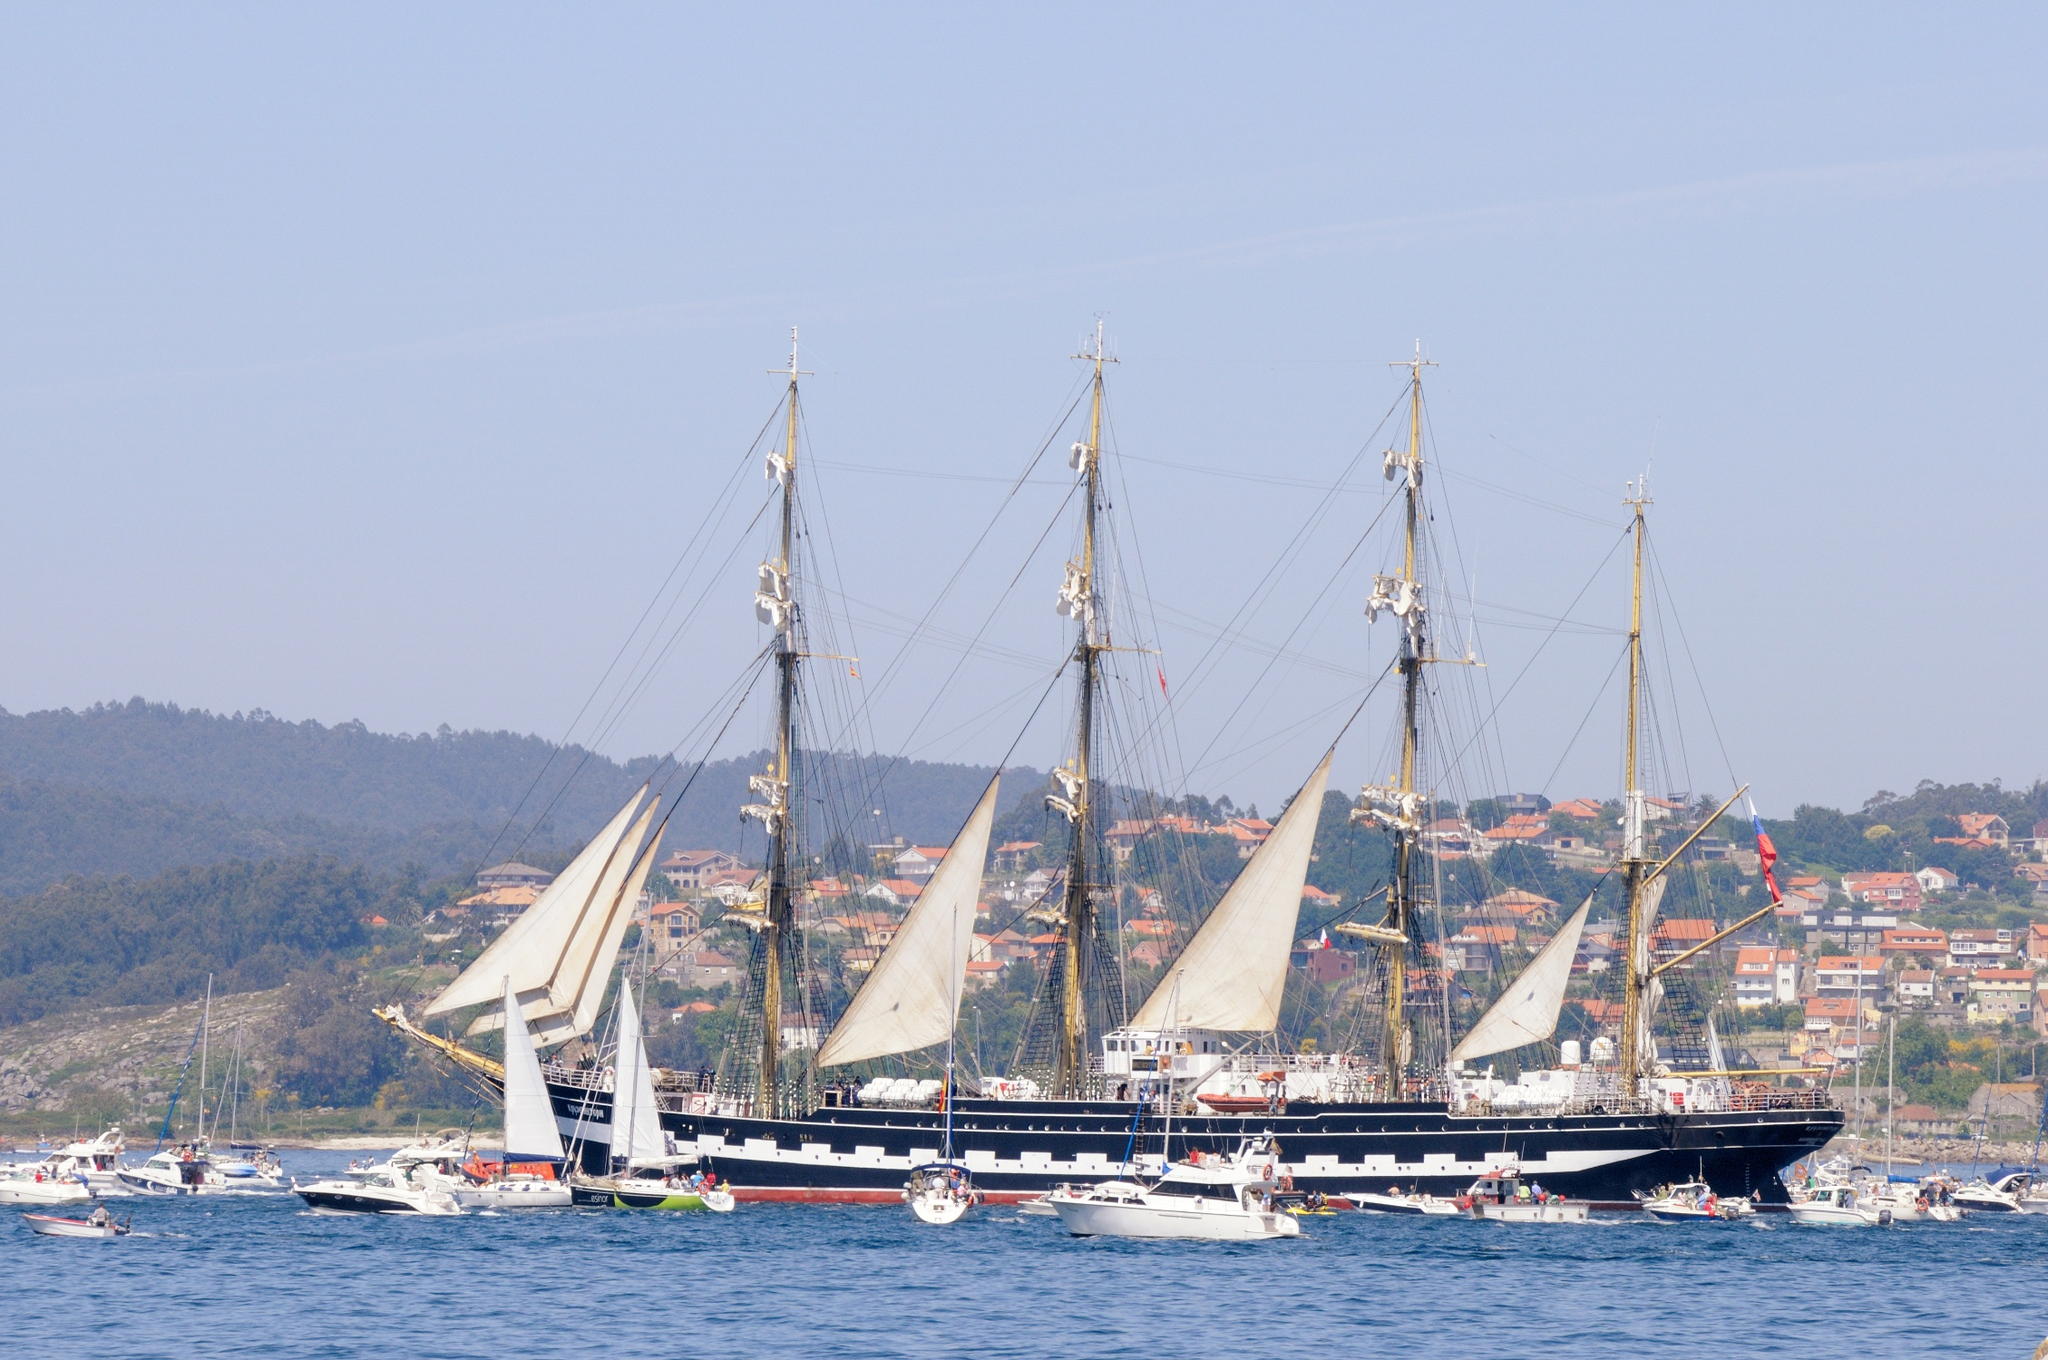What kind of event could this large ship be participating in? This ship, with its classic design and multiple masts, could likely be participating in a maritime festival or a tall ship regatta. These events celebrate traditional sailing vessels and often include races, parades, and public tours, allowing people to appreciate the maritime heritage and the craftsmanship of these vessels. 